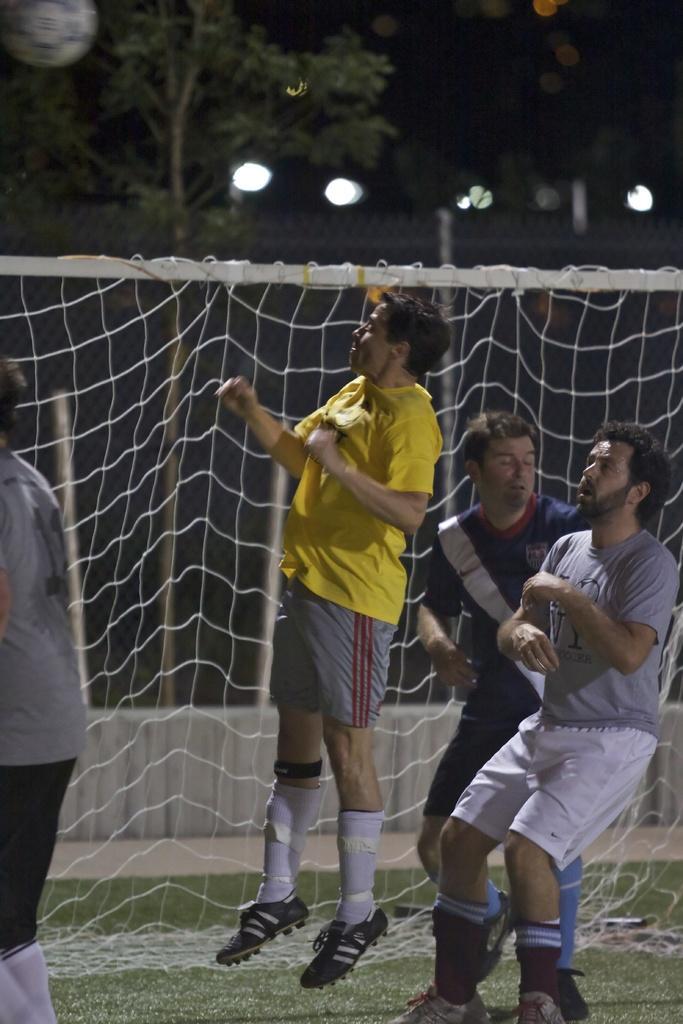Describe this image in one or two sentences. This is an image clicked in the dark. Here I can see four men are wearing t-shirts, shorts and shoes. Three men are standing and one man is jumping. At the back of these people I can see a net. In the background, I can see a tree and few lights. 